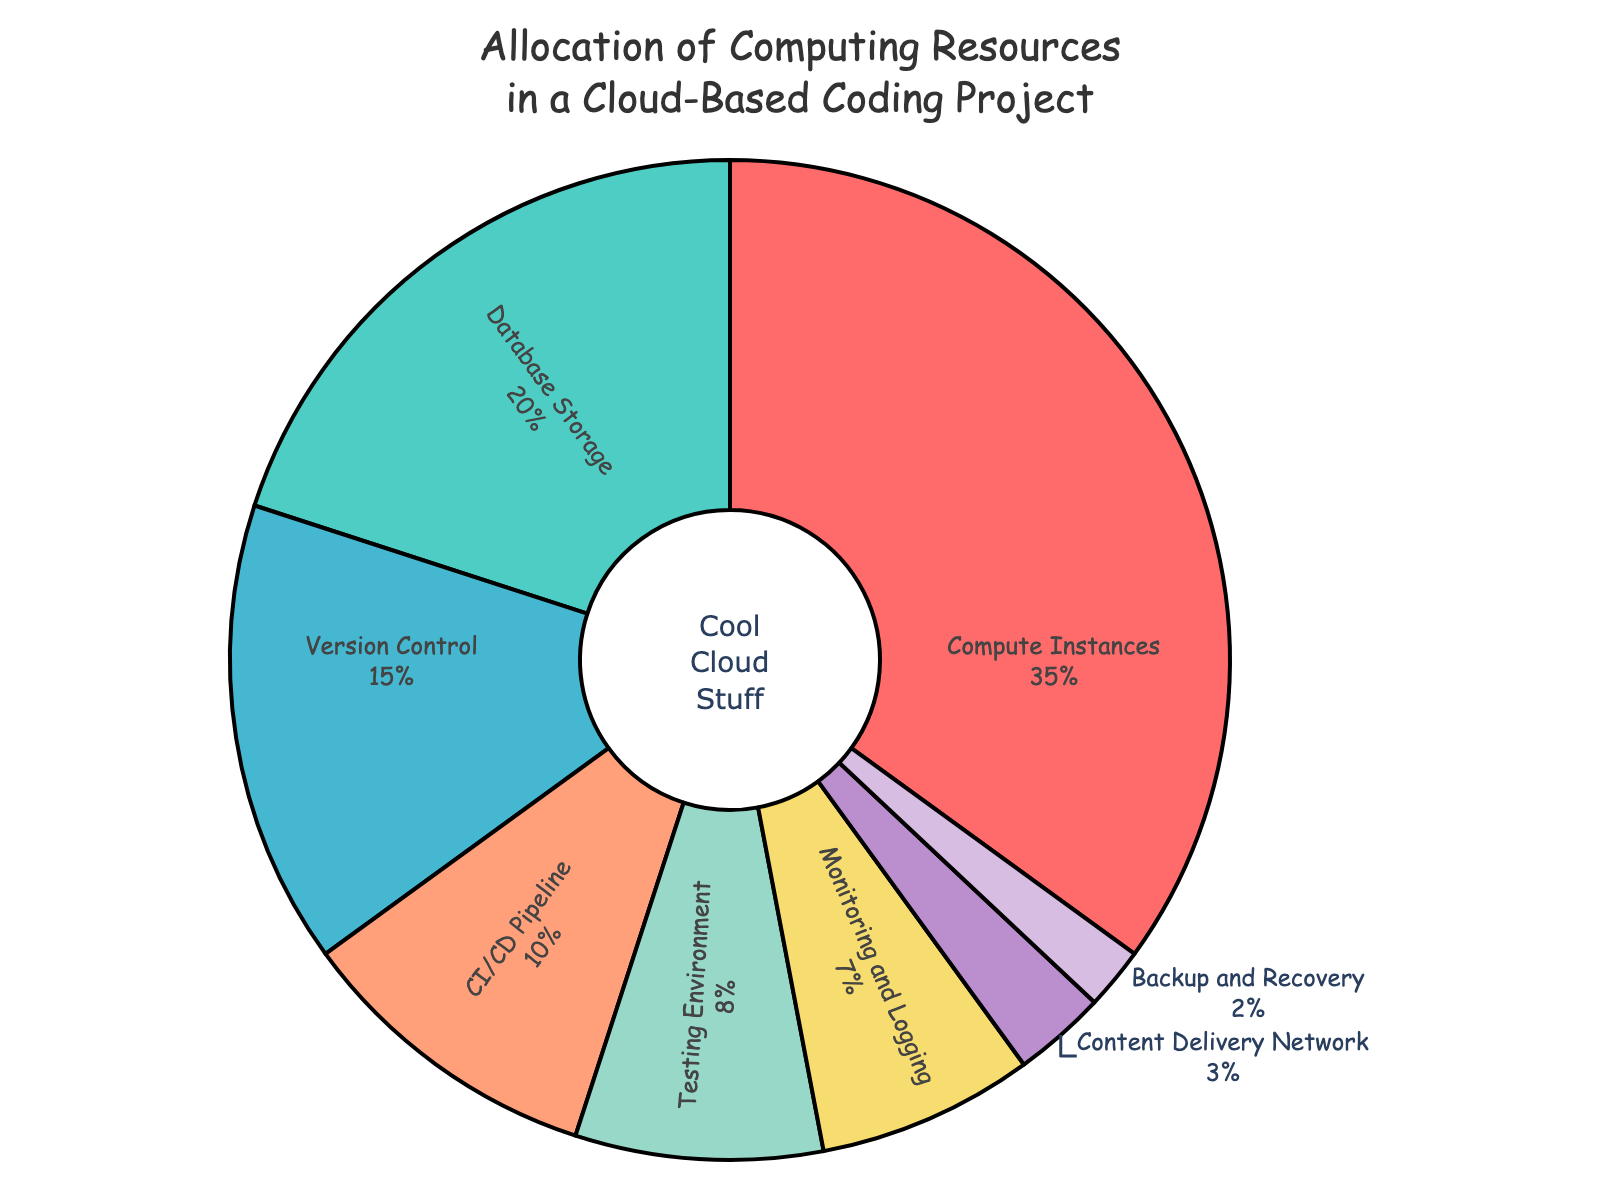what's the largest allocation of computing resources? From the pie chart, the largest section is labeled "Compute Instances," which occupies the largest portion visually. The label also indicates it with a percentage of 35%.
Answer: Compute Instances Which resource uses the least amount of computing resources? The smallest section of the pie chart is labeled "Backup and Recovery," occupying the smallest portion visually. The label indicates it with a percentage of 2%.
Answer: Backup and Recovery Which category has more computing resources: Version Control or Testing Environment? By comparing the two sections, Version Control occupies a larger portion of the pie chart, labeled with 15%, whereas the Testing Environment is labeled with 8%.
Answer: Version Control What is the difference in allocation between Database Storage and Content Delivery Network? The pie chart labels Database Storage with 20% and Content Delivery Network with 3%. Subtracting these values gives 20% - 3% = 17%.
Answer: 17% How much more resource allocation does the CI/CD Pipeline have compared to Monitoring and Logging? The pie chart labels CI/CD Pipeline with 10% and Monitoring and Logging with 7%. Subtracting these values gives 10% - 7% = 3%.
Answer: 3% What's the total percentage of resources allocated to both Database Storage and Testing Environment? The pie chart labels Database Storage with 20% and Testing Environment with 8%. Adding these values gives 20% + 8% = 28%.
Answer: 28% If you combine Backup and Recovery and Content Delivery Network, would they use more resources than Monitoring and Logging? The pie chart shows Backup and Recovery with 2% and Content Delivery Network with 3%. Adding these values gives 2% + 3% = 5%. Monitoring and Logging is labeled with 7%, which is greater than 5%.
Answer: No What's the difference in resource allocation between Backup and Recovery and Version Control? The pie chart labels Backup and Recovery with 2% and Version Control with 15%. Subtracting these values gives 15% - 2% = 13%.
Answer: 13% Which sections of the chart are shown in shades of green? The sections displayed in shades of green include Database Storage and Testing Environment. These are visually distinguishable based on their green coloring.
Answer: Database Storage, Testing Environment Which resource categories have a combined allocation less than 10%? The categories below 10% individually are Monitoring and Logging (7%), Content Delivery Network (3%), and Backup and Recovery (2%). Combined, they sum to 7% + 3% + 2% = 12%, so none of them together fall below 10%. Individually, they do fall below 10%.
Answer: Monitoring and Logging, Content Delivery Network, Backup and Recovery 